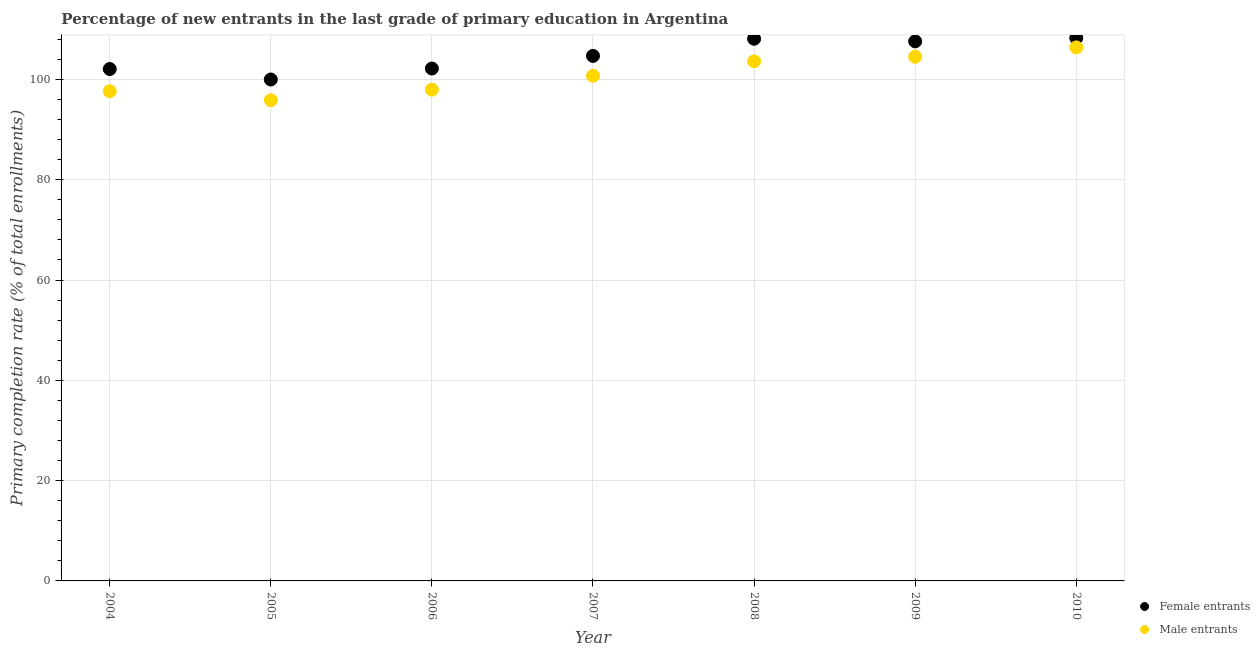What is the primary completion rate of male entrants in 2007?
Your answer should be compact. 100.72. Across all years, what is the maximum primary completion rate of male entrants?
Offer a terse response. 106.38. Across all years, what is the minimum primary completion rate of male entrants?
Give a very brief answer. 95.86. In which year was the primary completion rate of male entrants maximum?
Offer a terse response. 2010. What is the total primary completion rate of female entrants in the graph?
Ensure brevity in your answer.  732.86. What is the difference between the primary completion rate of female entrants in 2007 and that in 2008?
Offer a very short reply. -3.42. What is the difference between the primary completion rate of male entrants in 2008 and the primary completion rate of female entrants in 2005?
Your answer should be very brief. 3.63. What is the average primary completion rate of female entrants per year?
Your response must be concise. 104.69. In the year 2005, what is the difference between the primary completion rate of male entrants and primary completion rate of female entrants?
Provide a succinct answer. -4.12. What is the ratio of the primary completion rate of female entrants in 2006 to that in 2009?
Your answer should be compact. 0.95. Is the difference between the primary completion rate of female entrants in 2004 and 2008 greater than the difference between the primary completion rate of male entrants in 2004 and 2008?
Keep it short and to the point. No. What is the difference between the highest and the second highest primary completion rate of female entrants?
Offer a terse response. 0.15. What is the difference between the highest and the lowest primary completion rate of female entrants?
Your response must be concise. 8.27. Is the sum of the primary completion rate of male entrants in 2009 and 2010 greater than the maximum primary completion rate of female entrants across all years?
Offer a very short reply. Yes. Does the primary completion rate of male entrants monotonically increase over the years?
Your answer should be very brief. No. Is the primary completion rate of male entrants strictly greater than the primary completion rate of female entrants over the years?
Provide a succinct answer. No. How many dotlines are there?
Your answer should be compact. 2. How many years are there in the graph?
Give a very brief answer. 7. Does the graph contain grids?
Your answer should be compact. Yes. Where does the legend appear in the graph?
Your response must be concise. Bottom right. How are the legend labels stacked?
Make the answer very short. Vertical. What is the title of the graph?
Your response must be concise. Percentage of new entrants in the last grade of primary education in Argentina. What is the label or title of the X-axis?
Ensure brevity in your answer.  Year. What is the label or title of the Y-axis?
Your response must be concise. Primary completion rate (% of total enrollments). What is the Primary completion rate (% of total enrollments) of Female entrants in 2004?
Your response must be concise. 102.07. What is the Primary completion rate (% of total enrollments) in Male entrants in 2004?
Offer a very short reply. 97.65. What is the Primary completion rate (% of total enrollments) of Female entrants in 2005?
Make the answer very short. 99.98. What is the Primary completion rate (% of total enrollments) in Male entrants in 2005?
Make the answer very short. 95.86. What is the Primary completion rate (% of total enrollments) in Female entrants in 2006?
Keep it short and to the point. 102.17. What is the Primary completion rate (% of total enrollments) of Male entrants in 2006?
Offer a terse response. 97.96. What is the Primary completion rate (% of total enrollments) in Female entrants in 2007?
Your response must be concise. 104.69. What is the Primary completion rate (% of total enrollments) in Male entrants in 2007?
Offer a very short reply. 100.72. What is the Primary completion rate (% of total enrollments) in Female entrants in 2008?
Keep it short and to the point. 108.11. What is the Primary completion rate (% of total enrollments) of Male entrants in 2008?
Make the answer very short. 103.61. What is the Primary completion rate (% of total enrollments) of Female entrants in 2009?
Your answer should be compact. 107.59. What is the Primary completion rate (% of total enrollments) in Male entrants in 2009?
Offer a very short reply. 104.52. What is the Primary completion rate (% of total enrollments) in Female entrants in 2010?
Give a very brief answer. 108.26. What is the Primary completion rate (% of total enrollments) in Male entrants in 2010?
Give a very brief answer. 106.38. Across all years, what is the maximum Primary completion rate (% of total enrollments) of Female entrants?
Your response must be concise. 108.26. Across all years, what is the maximum Primary completion rate (% of total enrollments) in Male entrants?
Provide a succinct answer. 106.38. Across all years, what is the minimum Primary completion rate (% of total enrollments) in Female entrants?
Your answer should be very brief. 99.98. Across all years, what is the minimum Primary completion rate (% of total enrollments) of Male entrants?
Provide a short and direct response. 95.86. What is the total Primary completion rate (% of total enrollments) of Female entrants in the graph?
Your answer should be very brief. 732.86. What is the total Primary completion rate (% of total enrollments) in Male entrants in the graph?
Your answer should be very brief. 706.7. What is the difference between the Primary completion rate (% of total enrollments) of Female entrants in 2004 and that in 2005?
Ensure brevity in your answer.  2.09. What is the difference between the Primary completion rate (% of total enrollments) of Male entrants in 2004 and that in 2005?
Your answer should be compact. 1.79. What is the difference between the Primary completion rate (% of total enrollments) of Female entrants in 2004 and that in 2006?
Your response must be concise. -0.1. What is the difference between the Primary completion rate (% of total enrollments) of Male entrants in 2004 and that in 2006?
Your answer should be compact. -0.31. What is the difference between the Primary completion rate (% of total enrollments) of Female entrants in 2004 and that in 2007?
Provide a succinct answer. -2.62. What is the difference between the Primary completion rate (% of total enrollments) in Male entrants in 2004 and that in 2007?
Provide a succinct answer. -3.07. What is the difference between the Primary completion rate (% of total enrollments) of Female entrants in 2004 and that in 2008?
Offer a terse response. -6.03. What is the difference between the Primary completion rate (% of total enrollments) in Male entrants in 2004 and that in 2008?
Make the answer very short. -5.97. What is the difference between the Primary completion rate (% of total enrollments) of Female entrants in 2004 and that in 2009?
Ensure brevity in your answer.  -5.51. What is the difference between the Primary completion rate (% of total enrollments) in Male entrants in 2004 and that in 2009?
Offer a terse response. -6.88. What is the difference between the Primary completion rate (% of total enrollments) in Female entrants in 2004 and that in 2010?
Your answer should be very brief. -6.19. What is the difference between the Primary completion rate (% of total enrollments) in Male entrants in 2004 and that in 2010?
Your answer should be very brief. -8.74. What is the difference between the Primary completion rate (% of total enrollments) in Female entrants in 2005 and that in 2006?
Make the answer very short. -2.18. What is the difference between the Primary completion rate (% of total enrollments) of Male entrants in 2005 and that in 2006?
Your response must be concise. -2.1. What is the difference between the Primary completion rate (% of total enrollments) of Female entrants in 2005 and that in 2007?
Make the answer very short. -4.71. What is the difference between the Primary completion rate (% of total enrollments) of Male entrants in 2005 and that in 2007?
Keep it short and to the point. -4.86. What is the difference between the Primary completion rate (% of total enrollments) in Female entrants in 2005 and that in 2008?
Offer a very short reply. -8.12. What is the difference between the Primary completion rate (% of total enrollments) in Male entrants in 2005 and that in 2008?
Offer a terse response. -7.75. What is the difference between the Primary completion rate (% of total enrollments) of Female entrants in 2005 and that in 2009?
Ensure brevity in your answer.  -7.6. What is the difference between the Primary completion rate (% of total enrollments) of Male entrants in 2005 and that in 2009?
Ensure brevity in your answer.  -8.66. What is the difference between the Primary completion rate (% of total enrollments) of Female entrants in 2005 and that in 2010?
Provide a succinct answer. -8.27. What is the difference between the Primary completion rate (% of total enrollments) of Male entrants in 2005 and that in 2010?
Offer a terse response. -10.52. What is the difference between the Primary completion rate (% of total enrollments) in Female entrants in 2006 and that in 2007?
Provide a succinct answer. -2.52. What is the difference between the Primary completion rate (% of total enrollments) in Male entrants in 2006 and that in 2007?
Ensure brevity in your answer.  -2.76. What is the difference between the Primary completion rate (% of total enrollments) in Female entrants in 2006 and that in 2008?
Provide a short and direct response. -5.94. What is the difference between the Primary completion rate (% of total enrollments) in Male entrants in 2006 and that in 2008?
Provide a succinct answer. -5.65. What is the difference between the Primary completion rate (% of total enrollments) in Female entrants in 2006 and that in 2009?
Offer a terse response. -5.42. What is the difference between the Primary completion rate (% of total enrollments) in Male entrants in 2006 and that in 2009?
Offer a very short reply. -6.56. What is the difference between the Primary completion rate (% of total enrollments) of Female entrants in 2006 and that in 2010?
Keep it short and to the point. -6.09. What is the difference between the Primary completion rate (% of total enrollments) in Male entrants in 2006 and that in 2010?
Offer a terse response. -8.43. What is the difference between the Primary completion rate (% of total enrollments) in Female entrants in 2007 and that in 2008?
Ensure brevity in your answer.  -3.42. What is the difference between the Primary completion rate (% of total enrollments) in Male entrants in 2007 and that in 2008?
Give a very brief answer. -2.89. What is the difference between the Primary completion rate (% of total enrollments) in Female entrants in 2007 and that in 2009?
Ensure brevity in your answer.  -2.9. What is the difference between the Primary completion rate (% of total enrollments) in Male entrants in 2007 and that in 2009?
Keep it short and to the point. -3.8. What is the difference between the Primary completion rate (% of total enrollments) of Female entrants in 2007 and that in 2010?
Your answer should be very brief. -3.57. What is the difference between the Primary completion rate (% of total enrollments) in Male entrants in 2007 and that in 2010?
Offer a very short reply. -5.67. What is the difference between the Primary completion rate (% of total enrollments) in Female entrants in 2008 and that in 2009?
Provide a short and direct response. 0.52. What is the difference between the Primary completion rate (% of total enrollments) of Male entrants in 2008 and that in 2009?
Give a very brief answer. -0.91. What is the difference between the Primary completion rate (% of total enrollments) in Female entrants in 2008 and that in 2010?
Your answer should be very brief. -0.15. What is the difference between the Primary completion rate (% of total enrollments) in Male entrants in 2008 and that in 2010?
Ensure brevity in your answer.  -2.77. What is the difference between the Primary completion rate (% of total enrollments) of Female entrants in 2009 and that in 2010?
Offer a very short reply. -0.67. What is the difference between the Primary completion rate (% of total enrollments) in Male entrants in 2009 and that in 2010?
Offer a terse response. -1.86. What is the difference between the Primary completion rate (% of total enrollments) in Female entrants in 2004 and the Primary completion rate (% of total enrollments) in Male entrants in 2005?
Keep it short and to the point. 6.21. What is the difference between the Primary completion rate (% of total enrollments) of Female entrants in 2004 and the Primary completion rate (% of total enrollments) of Male entrants in 2006?
Your answer should be very brief. 4.12. What is the difference between the Primary completion rate (% of total enrollments) in Female entrants in 2004 and the Primary completion rate (% of total enrollments) in Male entrants in 2007?
Offer a very short reply. 1.36. What is the difference between the Primary completion rate (% of total enrollments) in Female entrants in 2004 and the Primary completion rate (% of total enrollments) in Male entrants in 2008?
Offer a terse response. -1.54. What is the difference between the Primary completion rate (% of total enrollments) in Female entrants in 2004 and the Primary completion rate (% of total enrollments) in Male entrants in 2009?
Your response must be concise. -2.45. What is the difference between the Primary completion rate (% of total enrollments) of Female entrants in 2004 and the Primary completion rate (% of total enrollments) of Male entrants in 2010?
Your response must be concise. -4.31. What is the difference between the Primary completion rate (% of total enrollments) of Female entrants in 2005 and the Primary completion rate (% of total enrollments) of Male entrants in 2006?
Provide a succinct answer. 2.03. What is the difference between the Primary completion rate (% of total enrollments) in Female entrants in 2005 and the Primary completion rate (% of total enrollments) in Male entrants in 2007?
Your answer should be very brief. -0.73. What is the difference between the Primary completion rate (% of total enrollments) in Female entrants in 2005 and the Primary completion rate (% of total enrollments) in Male entrants in 2008?
Provide a short and direct response. -3.63. What is the difference between the Primary completion rate (% of total enrollments) in Female entrants in 2005 and the Primary completion rate (% of total enrollments) in Male entrants in 2009?
Offer a very short reply. -4.54. What is the difference between the Primary completion rate (% of total enrollments) in Female entrants in 2005 and the Primary completion rate (% of total enrollments) in Male entrants in 2010?
Your answer should be compact. -6.4. What is the difference between the Primary completion rate (% of total enrollments) in Female entrants in 2006 and the Primary completion rate (% of total enrollments) in Male entrants in 2007?
Provide a short and direct response. 1.45. What is the difference between the Primary completion rate (% of total enrollments) in Female entrants in 2006 and the Primary completion rate (% of total enrollments) in Male entrants in 2008?
Your answer should be very brief. -1.44. What is the difference between the Primary completion rate (% of total enrollments) in Female entrants in 2006 and the Primary completion rate (% of total enrollments) in Male entrants in 2009?
Make the answer very short. -2.35. What is the difference between the Primary completion rate (% of total enrollments) of Female entrants in 2006 and the Primary completion rate (% of total enrollments) of Male entrants in 2010?
Make the answer very short. -4.22. What is the difference between the Primary completion rate (% of total enrollments) in Female entrants in 2007 and the Primary completion rate (% of total enrollments) in Male entrants in 2008?
Your answer should be compact. 1.08. What is the difference between the Primary completion rate (% of total enrollments) of Female entrants in 2007 and the Primary completion rate (% of total enrollments) of Male entrants in 2009?
Your response must be concise. 0.17. What is the difference between the Primary completion rate (% of total enrollments) of Female entrants in 2007 and the Primary completion rate (% of total enrollments) of Male entrants in 2010?
Ensure brevity in your answer.  -1.69. What is the difference between the Primary completion rate (% of total enrollments) of Female entrants in 2008 and the Primary completion rate (% of total enrollments) of Male entrants in 2009?
Offer a terse response. 3.58. What is the difference between the Primary completion rate (% of total enrollments) of Female entrants in 2008 and the Primary completion rate (% of total enrollments) of Male entrants in 2010?
Make the answer very short. 1.72. What is the difference between the Primary completion rate (% of total enrollments) in Female entrants in 2009 and the Primary completion rate (% of total enrollments) in Male entrants in 2010?
Your response must be concise. 1.2. What is the average Primary completion rate (% of total enrollments) of Female entrants per year?
Your answer should be compact. 104.69. What is the average Primary completion rate (% of total enrollments) in Male entrants per year?
Provide a succinct answer. 100.96. In the year 2004, what is the difference between the Primary completion rate (% of total enrollments) in Female entrants and Primary completion rate (% of total enrollments) in Male entrants?
Give a very brief answer. 4.43. In the year 2005, what is the difference between the Primary completion rate (% of total enrollments) in Female entrants and Primary completion rate (% of total enrollments) in Male entrants?
Make the answer very short. 4.12. In the year 2006, what is the difference between the Primary completion rate (% of total enrollments) of Female entrants and Primary completion rate (% of total enrollments) of Male entrants?
Keep it short and to the point. 4.21. In the year 2007, what is the difference between the Primary completion rate (% of total enrollments) in Female entrants and Primary completion rate (% of total enrollments) in Male entrants?
Offer a very short reply. 3.97. In the year 2008, what is the difference between the Primary completion rate (% of total enrollments) of Female entrants and Primary completion rate (% of total enrollments) of Male entrants?
Provide a short and direct response. 4.49. In the year 2009, what is the difference between the Primary completion rate (% of total enrollments) in Female entrants and Primary completion rate (% of total enrollments) in Male entrants?
Your response must be concise. 3.06. In the year 2010, what is the difference between the Primary completion rate (% of total enrollments) of Female entrants and Primary completion rate (% of total enrollments) of Male entrants?
Your answer should be very brief. 1.87. What is the ratio of the Primary completion rate (% of total enrollments) of Female entrants in 2004 to that in 2005?
Make the answer very short. 1.02. What is the ratio of the Primary completion rate (% of total enrollments) in Male entrants in 2004 to that in 2005?
Ensure brevity in your answer.  1.02. What is the ratio of the Primary completion rate (% of total enrollments) of Female entrants in 2004 to that in 2006?
Offer a terse response. 1. What is the ratio of the Primary completion rate (% of total enrollments) of Male entrants in 2004 to that in 2006?
Your answer should be compact. 1. What is the ratio of the Primary completion rate (% of total enrollments) in Female entrants in 2004 to that in 2007?
Ensure brevity in your answer.  0.97. What is the ratio of the Primary completion rate (% of total enrollments) of Male entrants in 2004 to that in 2007?
Offer a terse response. 0.97. What is the ratio of the Primary completion rate (% of total enrollments) in Female entrants in 2004 to that in 2008?
Make the answer very short. 0.94. What is the ratio of the Primary completion rate (% of total enrollments) in Male entrants in 2004 to that in 2008?
Offer a very short reply. 0.94. What is the ratio of the Primary completion rate (% of total enrollments) in Female entrants in 2004 to that in 2009?
Ensure brevity in your answer.  0.95. What is the ratio of the Primary completion rate (% of total enrollments) of Male entrants in 2004 to that in 2009?
Provide a succinct answer. 0.93. What is the ratio of the Primary completion rate (% of total enrollments) in Female entrants in 2004 to that in 2010?
Give a very brief answer. 0.94. What is the ratio of the Primary completion rate (% of total enrollments) in Male entrants in 2004 to that in 2010?
Give a very brief answer. 0.92. What is the ratio of the Primary completion rate (% of total enrollments) in Female entrants in 2005 to that in 2006?
Keep it short and to the point. 0.98. What is the ratio of the Primary completion rate (% of total enrollments) in Male entrants in 2005 to that in 2006?
Your answer should be very brief. 0.98. What is the ratio of the Primary completion rate (% of total enrollments) of Female entrants in 2005 to that in 2007?
Ensure brevity in your answer.  0.96. What is the ratio of the Primary completion rate (% of total enrollments) of Male entrants in 2005 to that in 2007?
Offer a terse response. 0.95. What is the ratio of the Primary completion rate (% of total enrollments) of Female entrants in 2005 to that in 2008?
Keep it short and to the point. 0.92. What is the ratio of the Primary completion rate (% of total enrollments) in Male entrants in 2005 to that in 2008?
Give a very brief answer. 0.93. What is the ratio of the Primary completion rate (% of total enrollments) in Female entrants in 2005 to that in 2009?
Ensure brevity in your answer.  0.93. What is the ratio of the Primary completion rate (% of total enrollments) of Male entrants in 2005 to that in 2009?
Offer a very short reply. 0.92. What is the ratio of the Primary completion rate (% of total enrollments) in Female entrants in 2005 to that in 2010?
Provide a short and direct response. 0.92. What is the ratio of the Primary completion rate (% of total enrollments) in Male entrants in 2005 to that in 2010?
Make the answer very short. 0.9. What is the ratio of the Primary completion rate (% of total enrollments) of Female entrants in 2006 to that in 2007?
Ensure brevity in your answer.  0.98. What is the ratio of the Primary completion rate (% of total enrollments) of Male entrants in 2006 to that in 2007?
Provide a short and direct response. 0.97. What is the ratio of the Primary completion rate (% of total enrollments) of Female entrants in 2006 to that in 2008?
Provide a short and direct response. 0.95. What is the ratio of the Primary completion rate (% of total enrollments) in Male entrants in 2006 to that in 2008?
Offer a very short reply. 0.95. What is the ratio of the Primary completion rate (% of total enrollments) of Female entrants in 2006 to that in 2009?
Provide a succinct answer. 0.95. What is the ratio of the Primary completion rate (% of total enrollments) in Male entrants in 2006 to that in 2009?
Your answer should be very brief. 0.94. What is the ratio of the Primary completion rate (% of total enrollments) in Female entrants in 2006 to that in 2010?
Your response must be concise. 0.94. What is the ratio of the Primary completion rate (% of total enrollments) of Male entrants in 2006 to that in 2010?
Provide a succinct answer. 0.92. What is the ratio of the Primary completion rate (% of total enrollments) of Female entrants in 2007 to that in 2008?
Your response must be concise. 0.97. What is the ratio of the Primary completion rate (% of total enrollments) of Male entrants in 2007 to that in 2008?
Your answer should be very brief. 0.97. What is the ratio of the Primary completion rate (% of total enrollments) in Female entrants in 2007 to that in 2009?
Offer a terse response. 0.97. What is the ratio of the Primary completion rate (% of total enrollments) of Male entrants in 2007 to that in 2009?
Your answer should be very brief. 0.96. What is the ratio of the Primary completion rate (% of total enrollments) of Female entrants in 2007 to that in 2010?
Offer a very short reply. 0.97. What is the ratio of the Primary completion rate (% of total enrollments) in Male entrants in 2007 to that in 2010?
Offer a terse response. 0.95. What is the ratio of the Primary completion rate (% of total enrollments) of Male entrants in 2008 to that in 2010?
Make the answer very short. 0.97. What is the ratio of the Primary completion rate (% of total enrollments) of Male entrants in 2009 to that in 2010?
Provide a short and direct response. 0.98. What is the difference between the highest and the second highest Primary completion rate (% of total enrollments) in Female entrants?
Ensure brevity in your answer.  0.15. What is the difference between the highest and the second highest Primary completion rate (% of total enrollments) in Male entrants?
Provide a short and direct response. 1.86. What is the difference between the highest and the lowest Primary completion rate (% of total enrollments) in Female entrants?
Offer a terse response. 8.27. What is the difference between the highest and the lowest Primary completion rate (% of total enrollments) of Male entrants?
Provide a short and direct response. 10.52. 